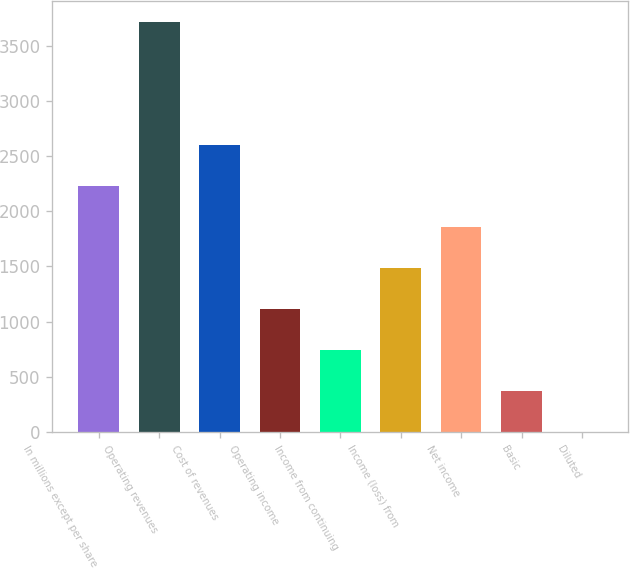Convert chart to OTSL. <chart><loc_0><loc_0><loc_500><loc_500><bar_chart><fcel>In millions except per share<fcel>Operating revenues<fcel>Cost of revenues<fcel>Operating income<fcel>Income from continuing<fcel>Income (loss) from<fcel>Net income<fcel>Basic<fcel>Diluted<nl><fcel>2231.89<fcel>3719<fcel>2603.67<fcel>1116.55<fcel>744.77<fcel>1488.33<fcel>1860.11<fcel>372.99<fcel>1.21<nl></chart> 